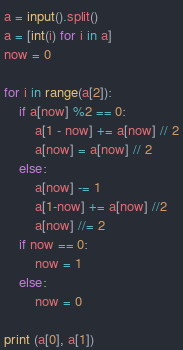<code> <loc_0><loc_0><loc_500><loc_500><_Python_>a = input().split()
a = [int(i) for i in a]
now = 0

for i in range(a[2]):
	if a[now] %2 == 0:
		a[1 - now] += a[now] // 2
		a[now] = a[now] // 2
	else:
		a[now] -= 1
		a[1-now] += a[now] //2
		a[now] //= 2
	if now == 0:
		now = 1
	else:
		now = 0
		
print (a[0], a[1])</code> 